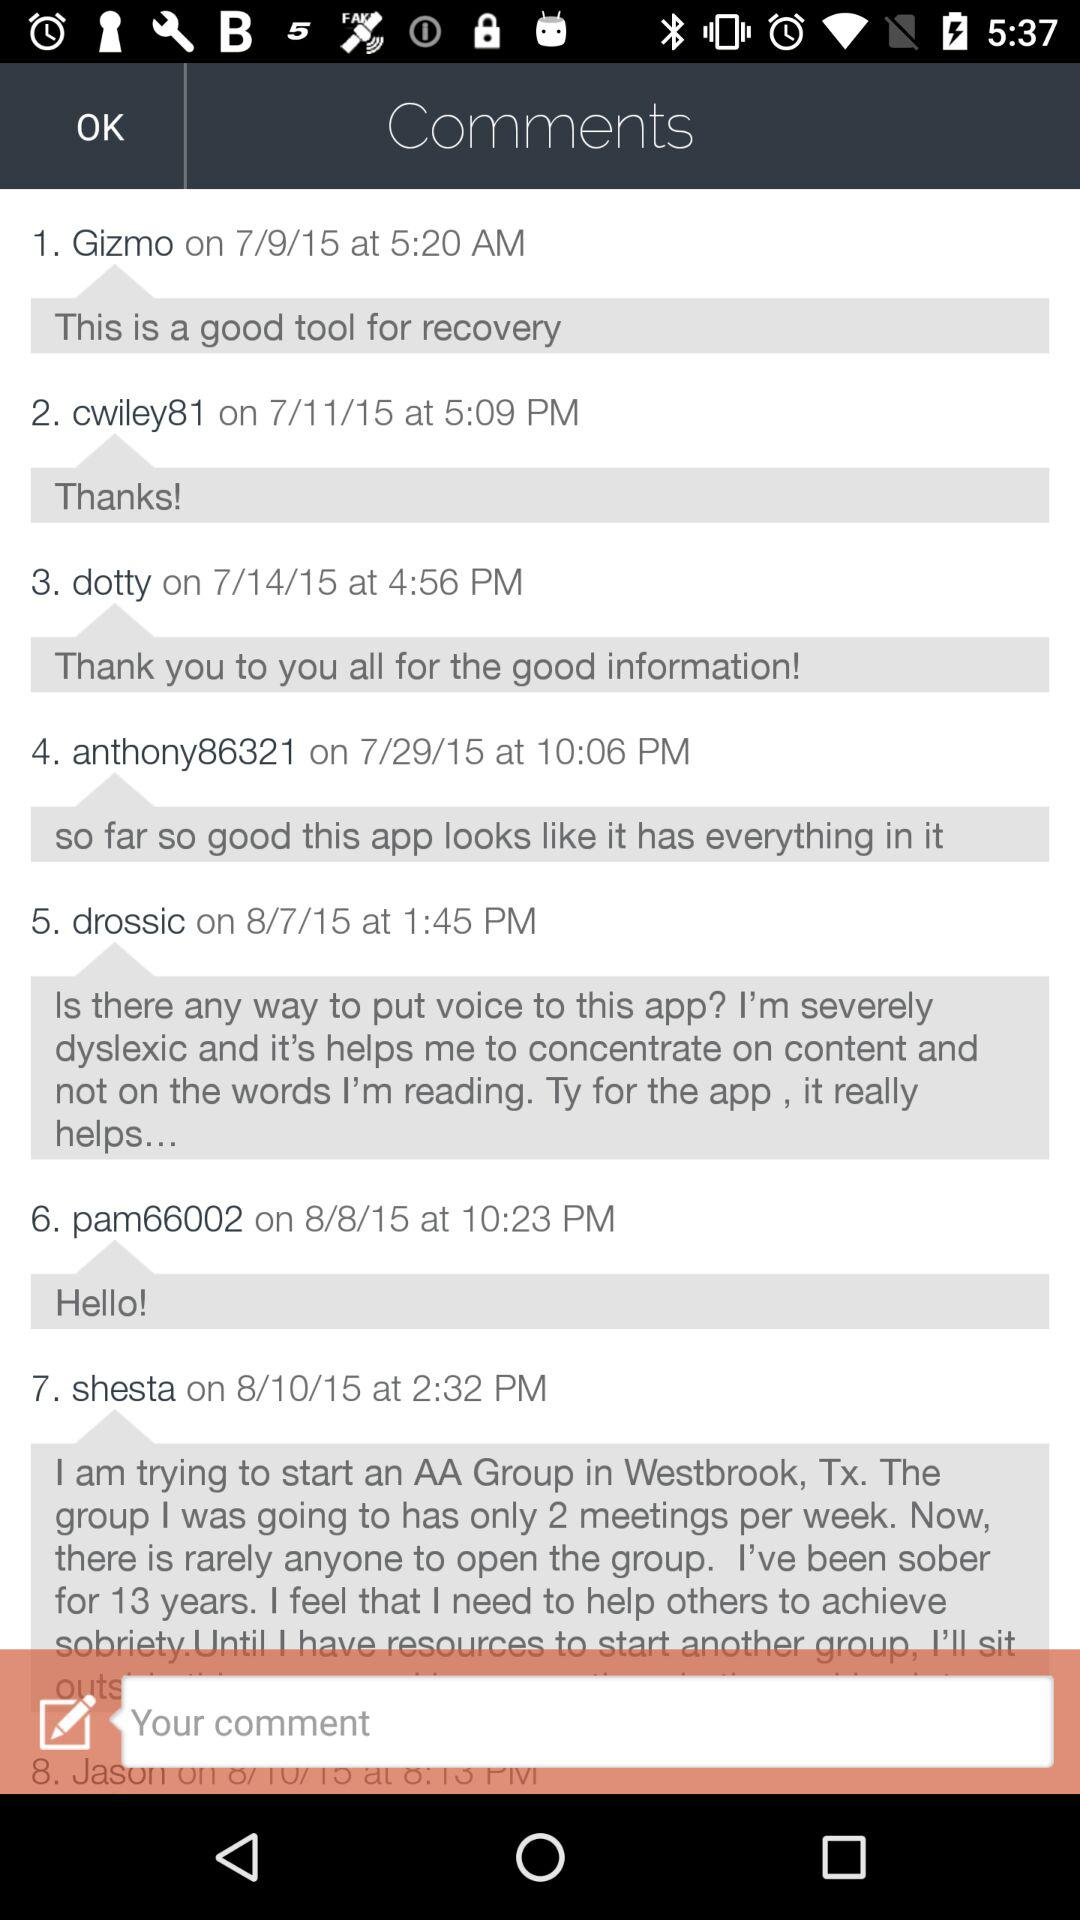When did "drossic" post the comment? "drossic" posted the comment on August 7, 2015 at 1:45 p.m. 